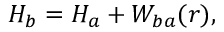Convert formula to latex. <formula><loc_0><loc_0><loc_500><loc_500>H _ { b } = H _ { a } + W _ { b a } ( r ) ,</formula> 